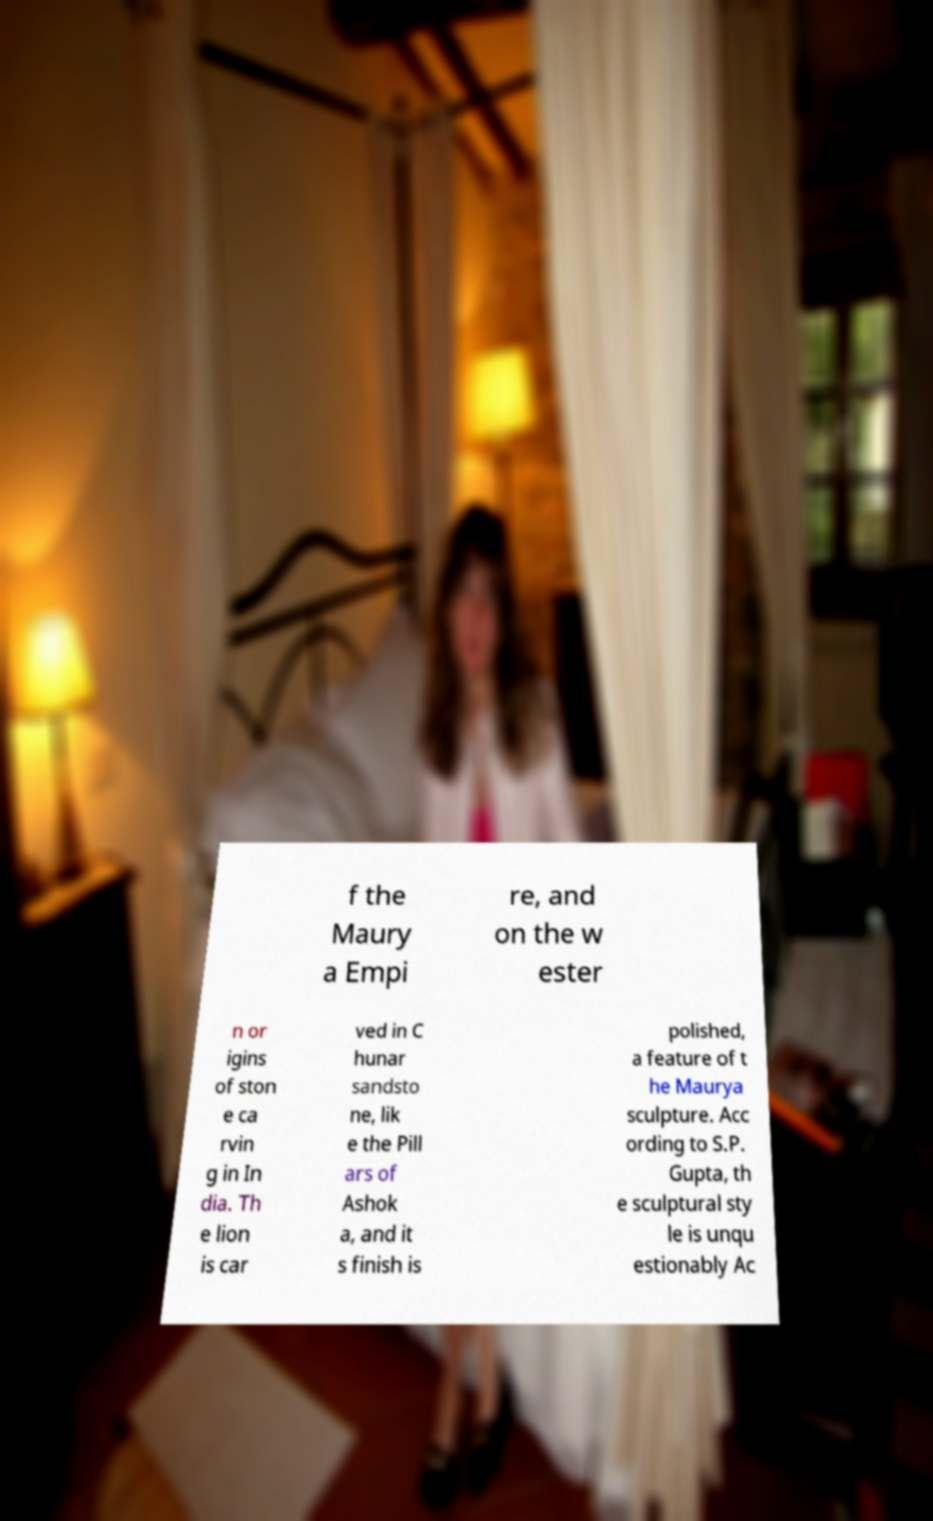Please read and relay the text visible in this image. What does it say? f the Maury a Empi re, and on the w ester n or igins of ston e ca rvin g in In dia. Th e lion is car ved in C hunar sandsto ne, lik e the Pill ars of Ashok a, and it s finish is polished, a feature of t he Maurya sculpture. Acc ording to S.P. Gupta, th e sculptural sty le is unqu estionably Ac 